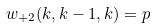Convert formula to latex. <formula><loc_0><loc_0><loc_500><loc_500>w _ { + 2 } ( k , k - 1 , k ) = p</formula> 